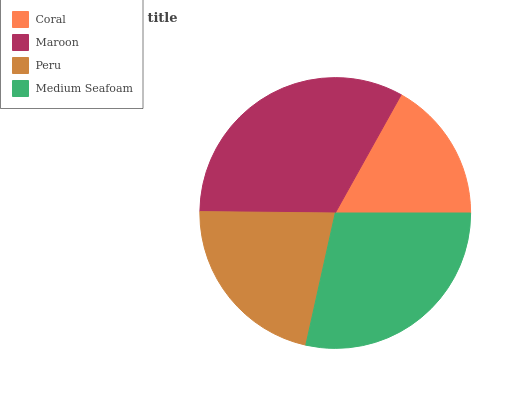Is Coral the minimum?
Answer yes or no. Yes. Is Maroon the maximum?
Answer yes or no. Yes. Is Peru the minimum?
Answer yes or no. No. Is Peru the maximum?
Answer yes or no. No. Is Maroon greater than Peru?
Answer yes or no. Yes. Is Peru less than Maroon?
Answer yes or no. Yes. Is Peru greater than Maroon?
Answer yes or no. No. Is Maroon less than Peru?
Answer yes or no. No. Is Medium Seafoam the high median?
Answer yes or no. Yes. Is Peru the low median?
Answer yes or no. Yes. Is Maroon the high median?
Answer yes or no. No. Is Coral the low median?
Answer yes or no. No. 